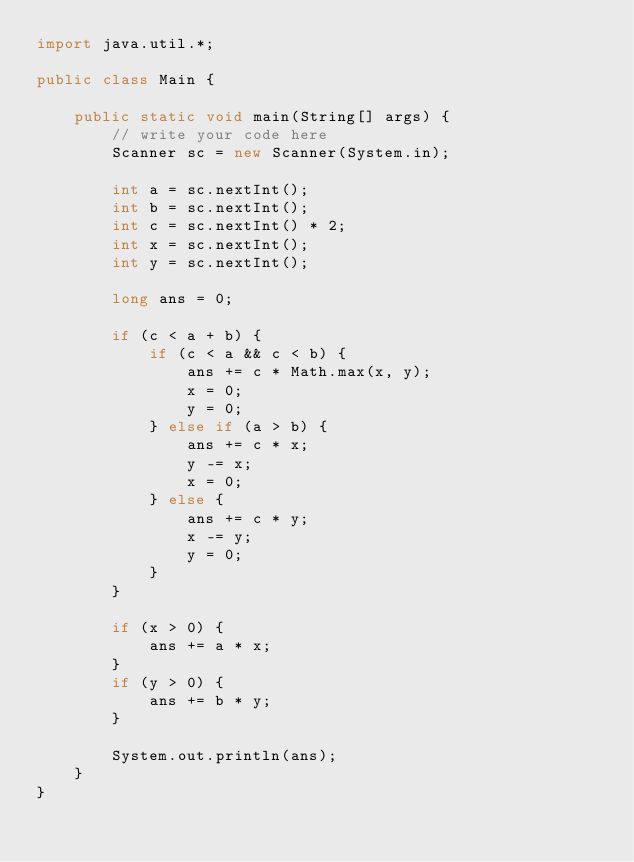<code> <loc_0><loc_0><loc_500><loc_500><_Java_>import java.util.*;

public class Main {

    public static void main(String[] args) {
        // write your code here
        Scanner sc = new Scanner(System.in);

        int a = sc.nextInt();
        int b = sc.nextInt();
        int c = sc.nextInt() * 2;
        int x = sc.nextInt();
        int y = sc.nextInt();

        long ans = 0;

        if (c < a + b) {
            if (c < a && c < b) {
                ans += c * Math.max(x, y);
                x = 0;
                y = 0;
            } else if (a > b) {
                ans += c * x;
                y -= x;
                x = 0;
            } else {
                ans += c * y;
                x -= y;
                y = 0;
            }
        }

        if (x > 0) {
            ans += a * x;
        }
        if (y > 0) {
            ans += b * y;
        }

        System.out.println(ans);
    }
}</code> 